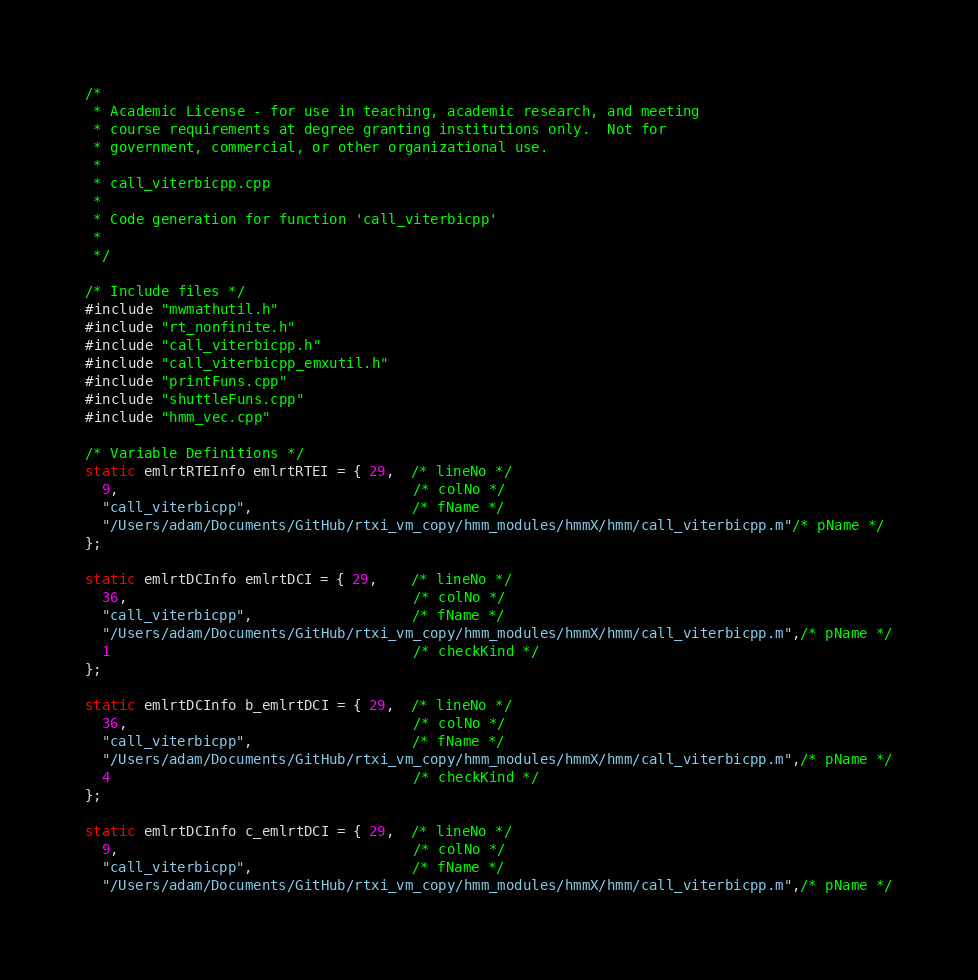<code> <loc_0><loc_0><loc_500><loc_500><_C++_>/*
 * Academic License - for use in teaching, academic research, and meeting
 * course requirements at degree granting institutions only.  Not for
 * government, commercial, or other organizational use.
 *
 * call_viterbicpp.cpp
 *
 * Code generation for function 'call_viterbicpp'
 *
 */

/* Include files */
#include "mwmathutil.h"
#include "rt_nonfinite.h"
#include "call_viterbicpp.h"
#include "call_viterbicpp_emxutil.h"
#include "printFuns.cpp"
#include "shuttleFuns.cpp"
#include "hmm_vec.cpp"

/* Variable Definitions */
static emlrtRTEInfo emlrtRTEI = { 29,  /* lineNo */
  9,                                   /* colNo */
  "call_viterbicpp",                   /* fName */
  "/Users/adam/Documents/GitHub/rtxi_vm_copy/hmm_modules/hmmX/hmm/call_viterbicpp.m"/* pName */
};

static emlrtDCInfo emlrtDCI = { 29,    /* lineNo */
  36,                                  /* colNo */
  "call_viterbicpp",                   /* fName */
  "/Users/adam/Documents/GitHub/rtxi_vm_copy/hmm_modules/hmmX/hmm/call_viterbicpp.m",/* pName */
  1                                    /* checkKind */
};

static emlrtDCInfo b_emlrtDCI = { 29,  /* lineNo */
  36,                                  /* colNo */
  "call_viterbicpp",                   /* fName */
  "/Users/adam/Documents/GitHub/rtxi_vm_copy/hmm_modules/hmmX/hmm/call_viterbicpp.m",/* pName */
  4                                    /* checkKind */
};

static emlrtDCInfo c_emlrtDCI = { 29,  /* lineNo */
  9,                                   /* colNo */
  "call_viterbicpp",                   /* fName */
  "/Users/adam/Documents/GitHub/rtxi_vm_copy/hmm_modules/hmmX/hmm/call_viterbicpp.m",/* pName */</code> 